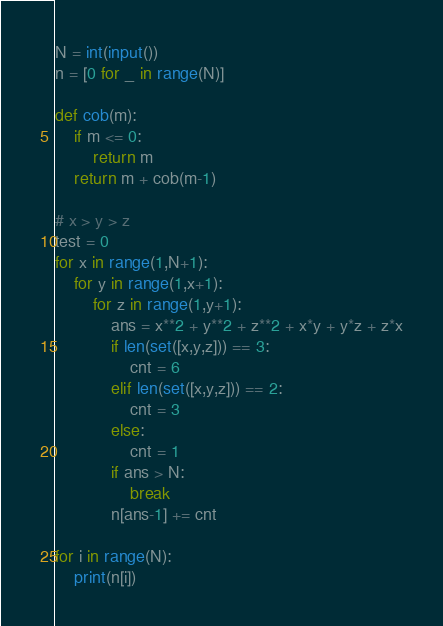Convert code to text. <code><loc_0><loc_0><loc_500><loc_500><_Python_>N = int(input())
n = [0 for _ in range(N)]

def cob(m):
    if m <= 0:
        return m
    return m + cob(m-1)

# x > y > z
test = 0
for x in range(1,N+1):
    for y in range(1,x+1):
        for z in range(1,y+1):
            ans = x**2 + y**2 + z**2 + x*y + y*z + z*x
            if len(set([x,y,z])) == 3:
                cnt = 6
            elif len(set([x,y,z])) == 2:
                cnt = 3
            else:
                cnt = 1
            if ans > N:
                break
            n[ans-1] += cnt

for i in range(N):
    print(n[i])

</code> 